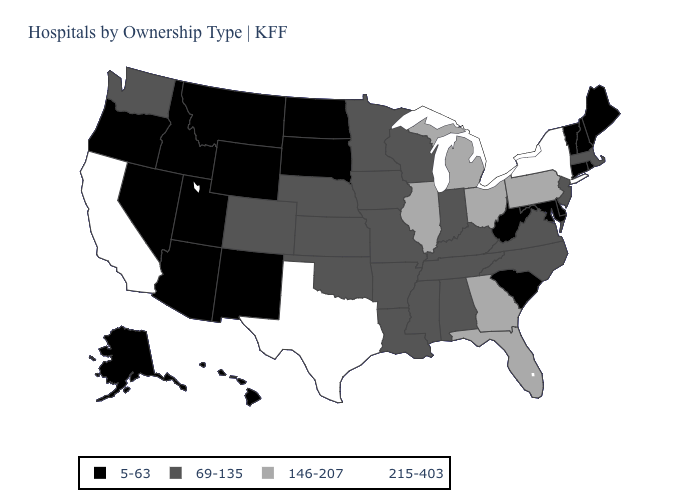Name the states that have a value in the range 146-207?
Be succinct. Florida, Georgia, Illinois, Michigan, Ohio, Pennsylvania. Name the states that have a value in the range 69-135?
Short answer required. Alabama, Arkansas, Colorado, Indiana, Iowa, Kansas, Kentucky, Louisiana, Massachusetts, Minnesota, Mississippi, Missouri, Nebraska, New Jersey, North Carolina, Oklahoma, Tennessee, Virginia, Washington, Wisconsin. Does the map have missing data?
Concise answer only. No. Name the states that have a value in the range 146-207?
Concise answer only. Florida, Georgia, Illinois, Michigan, Ohio, Pennsylvania. Among the states that border Illinois , which have the lowest value?
Short answer required. Indiana, Iowa, Kentucky, Missouri, Wisconsin. Does Minnesota have a higher value than Rhode Island?
Be succinct. Yes. Does North Dakota have the lowest value in the USA?
Give a very brief answer. Yes. Which states hav the highest value in the Northeast?
Answer briefly. New York. What is the value of Florida?
Be succinct. 146-207. What is the value of Iowa?
Concise answer only. 69-135. Name the states that have a value in the range 69-135?
Write a very short answer. Alabama, Arkansas, Colorado, Indiana, Iowa, Kansas, Kentucky, Louisiana, Massachusetts, Minnesota, Mississippi, Missouri, Nebraska, New Jersey, North Carolina, Oklahoma, Tennessee, Virginia, Washington, Wisconsin. What is the value of Utah?
Quick response, please. 5-63. What is the lowest value in the USA?
Concise answer only. 5-63. Which states have the highest value in the USA?
Quick response, please. California, New York, Texas. Does New Hampshire have a higher value than Kentucky?
Be succinct. No. 